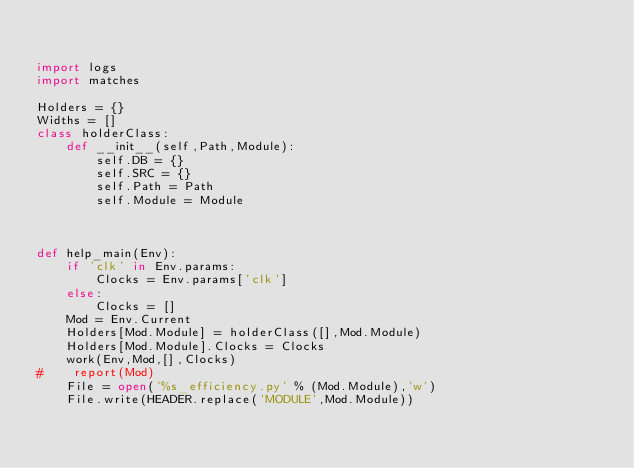<code> <loc_0><loc_0><loc_500><loc_500><_Python_>

import logs
import matches

Holders = {}
Widths = []
class holderClass:
    def __init__(self,Path,Module):
        self.DB = {}
        self.SRC = {}
        self.Path = Path
        self.Module = Module



def help_main(Env):
    if 'clk' in Env.params:
        Clocks = Env.params['clk']
    else:
        Clocks = []
    Mod = Env.Current
    Holders[Mod.Module] = holderClass([],Mod.Module)
    Holders[Mod.Module].Clocks = Clocks
    work(Env,Mod,[],Clocks)
#    report(Mod)
    File = open('%s_efficiency.py' % (Mod.Module),'w')
    File.write(HEADER.replace('MODULE',Mod.Module))</code> 